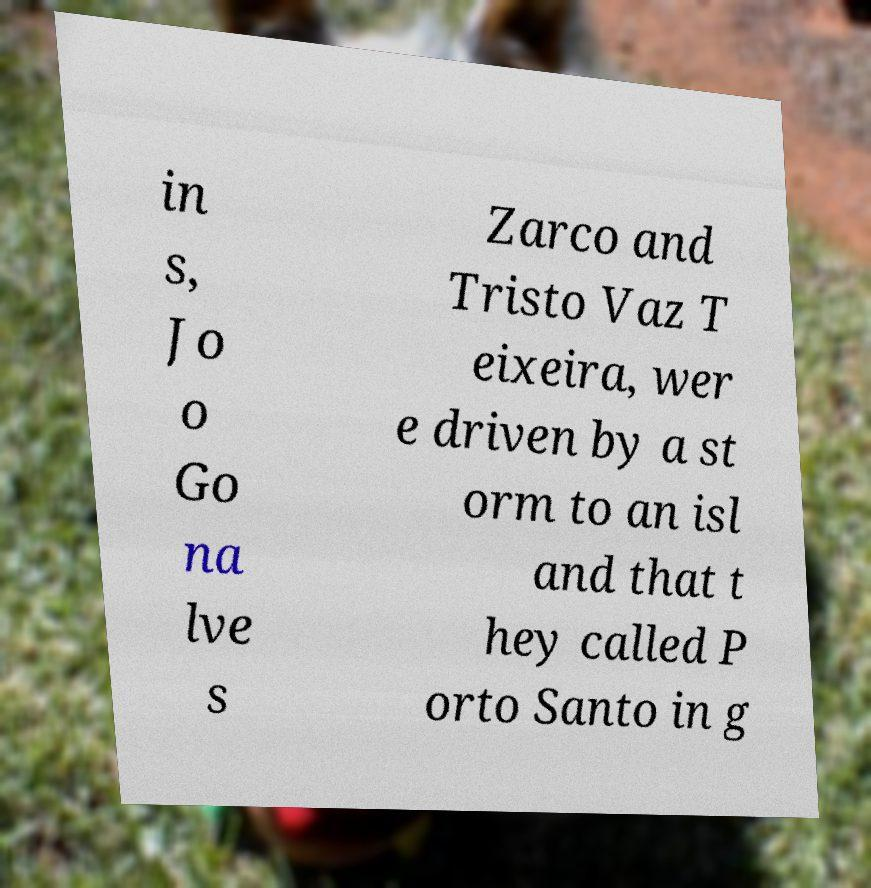Could you assist in decoding the text presented in this image and type it out clearly? in s, Jo o Go na lve s Zarco and Tristo Vaz T eixeira, wer e driven by a st orm to an isl and that t hey called P orto Santo in g 